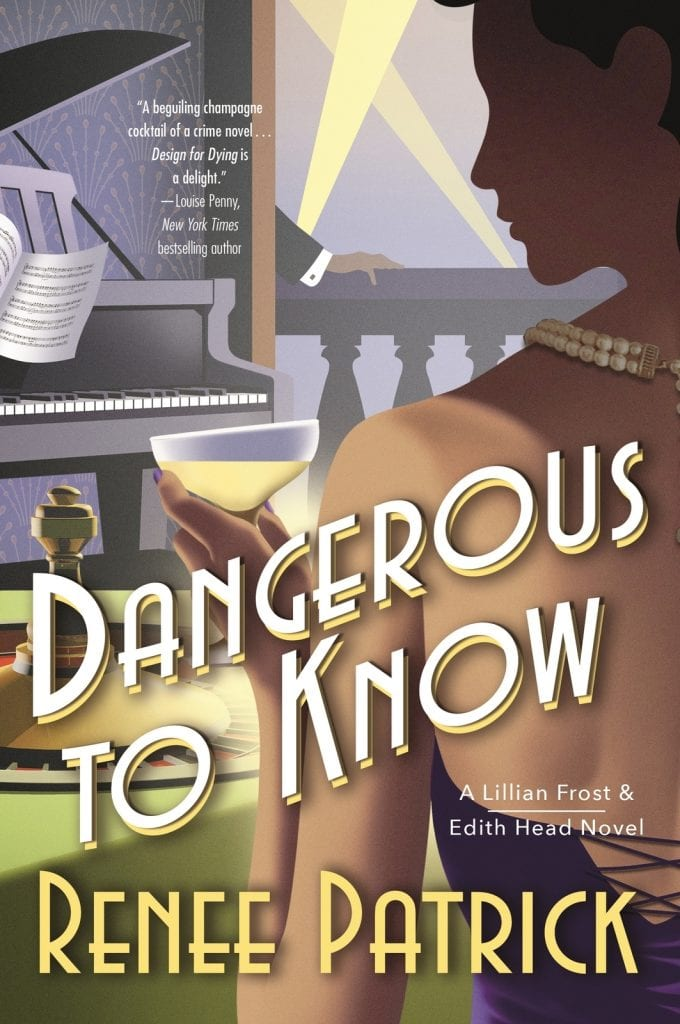Can you describe the atmosphere or setting implied by the cover of the book? The book cover suggests a luxurious and perhaps suspenseful setting, indicated by objects like a champagne glass and a grand piano, alongside the shadowy figure in the foreground. The presence of musical elements with a backdrop of what appears to be a party scene encapsulates a high-society event where secrets might linger just beneath the surface. 